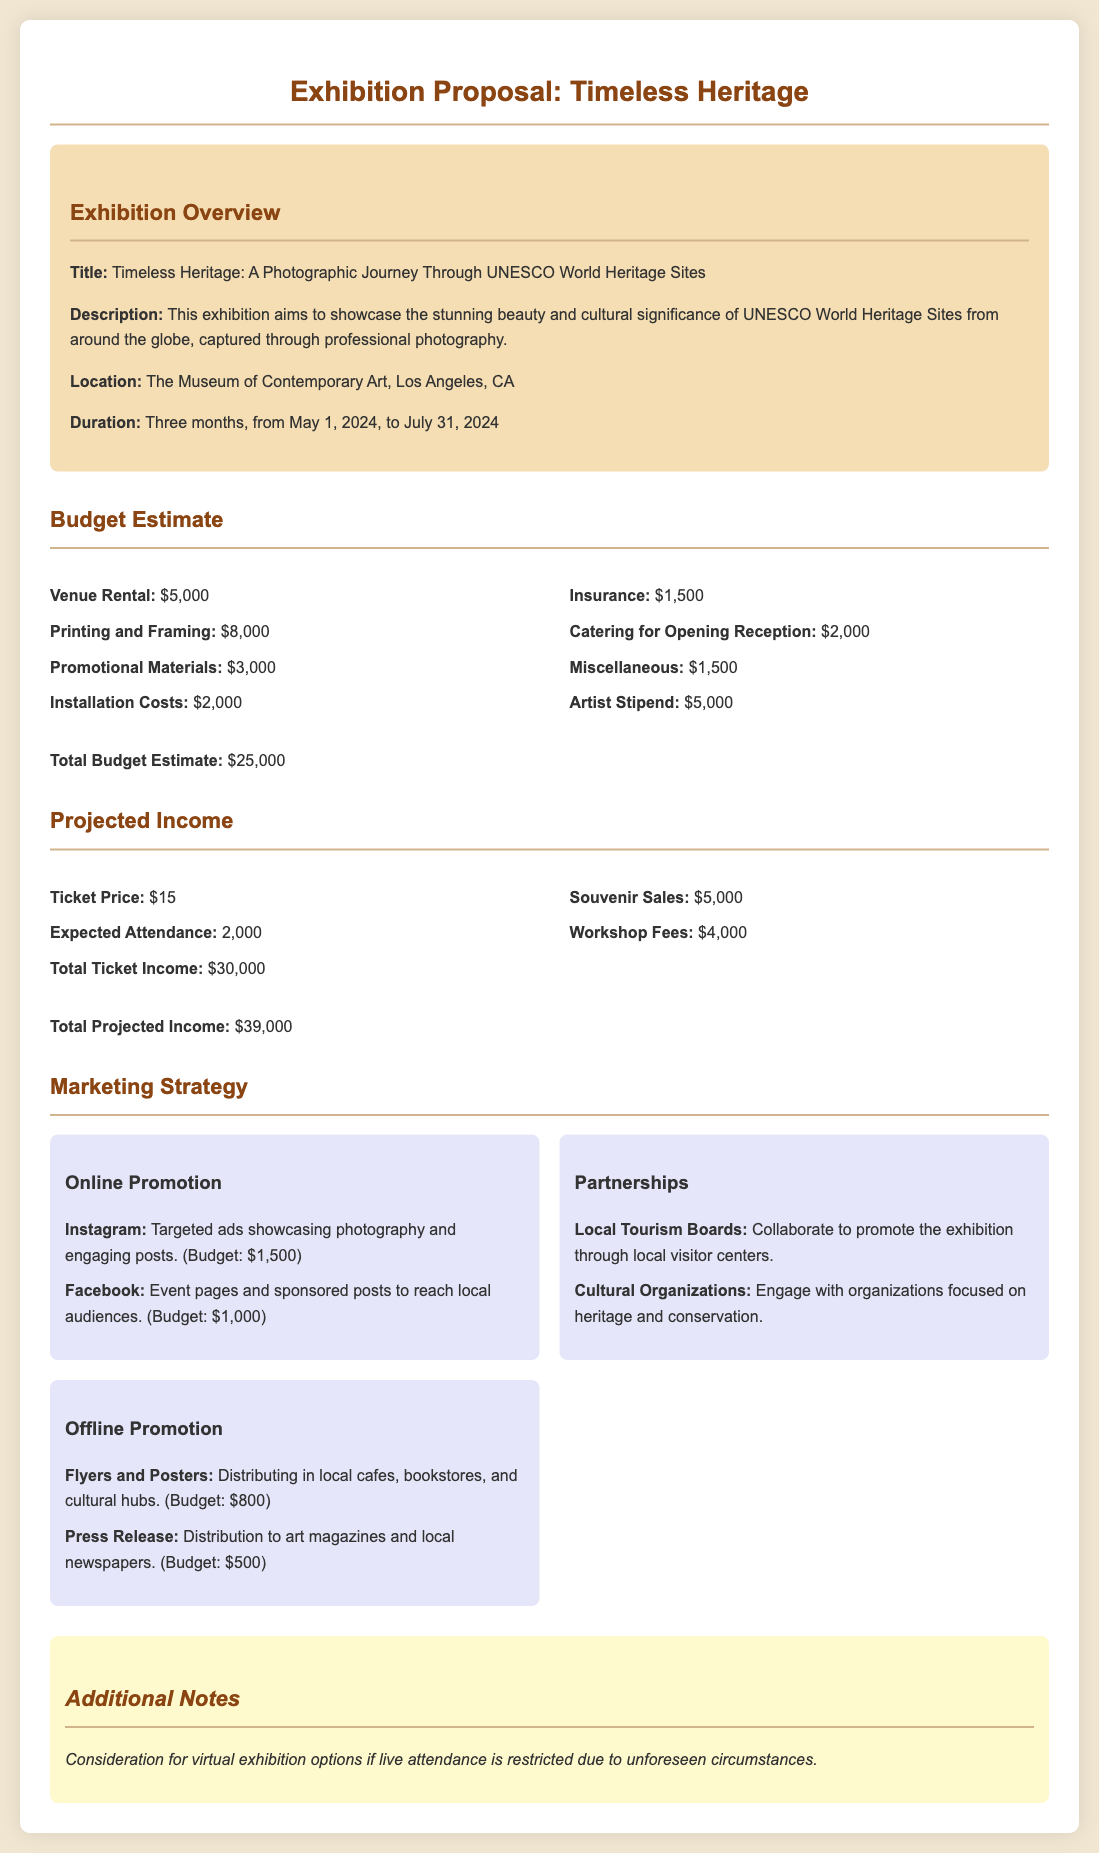What is the title of the exhibition? The title of the exhibition is explicitly stated in the document as "Timeless Heritage: A Photographic Journey Through UNESCO World Heritage Sites."
Answer: Timeless Heritage: A Photographic Journey Through UNESCO World Heritage Sites What is the total budget estimate? The document provides a summary of the total budget estimate at the end of the budget section, which is $25,000.
Answer: $25,000 What is the ticket price? The ticket price is mentioned under Projected Income, which states the ticket price is $15.
Answer: $15 How many expected attendees are projected? The expected attendance is given in the Projected Income section, which indicates 2,000 attendees.
Answer: 2,000 What location is specified for the exhibition? The document lists the venue for the exhibition as "The Museum of Contemporary Art, Los Angeles, CA."
Answer: The Museum of Contemporary Art, Los Angeles, CA What is the budget for Instagram advertising? The marketing strategy section details a $1,500 budget for targeted ads on Instagram.
Answer: $1,500 How long will the exhibition last? The duration of the exhibition is provided in the overview, stating it will run for three months, from May 1, 2024, to July 31, 2024.
Answer: Three months What is the estimated total income from ticket sales? The document mentions the total ticket income expected to be $30,000 under the Projected Income section.
Answer: $30,000 What type of organizations will be engaged for partnerships? The document specifies engaging with "Cultural Organizations" and "Local Tourism Boards" for partnerships.
Answer: Cultural Organizations and Local Tourism Boards What additional option is considered if attendance is restricted? An additional note in the document mentions considering "virtual exhibition options" if live attendance is restricted.
Answer: Virtual exhibition options 